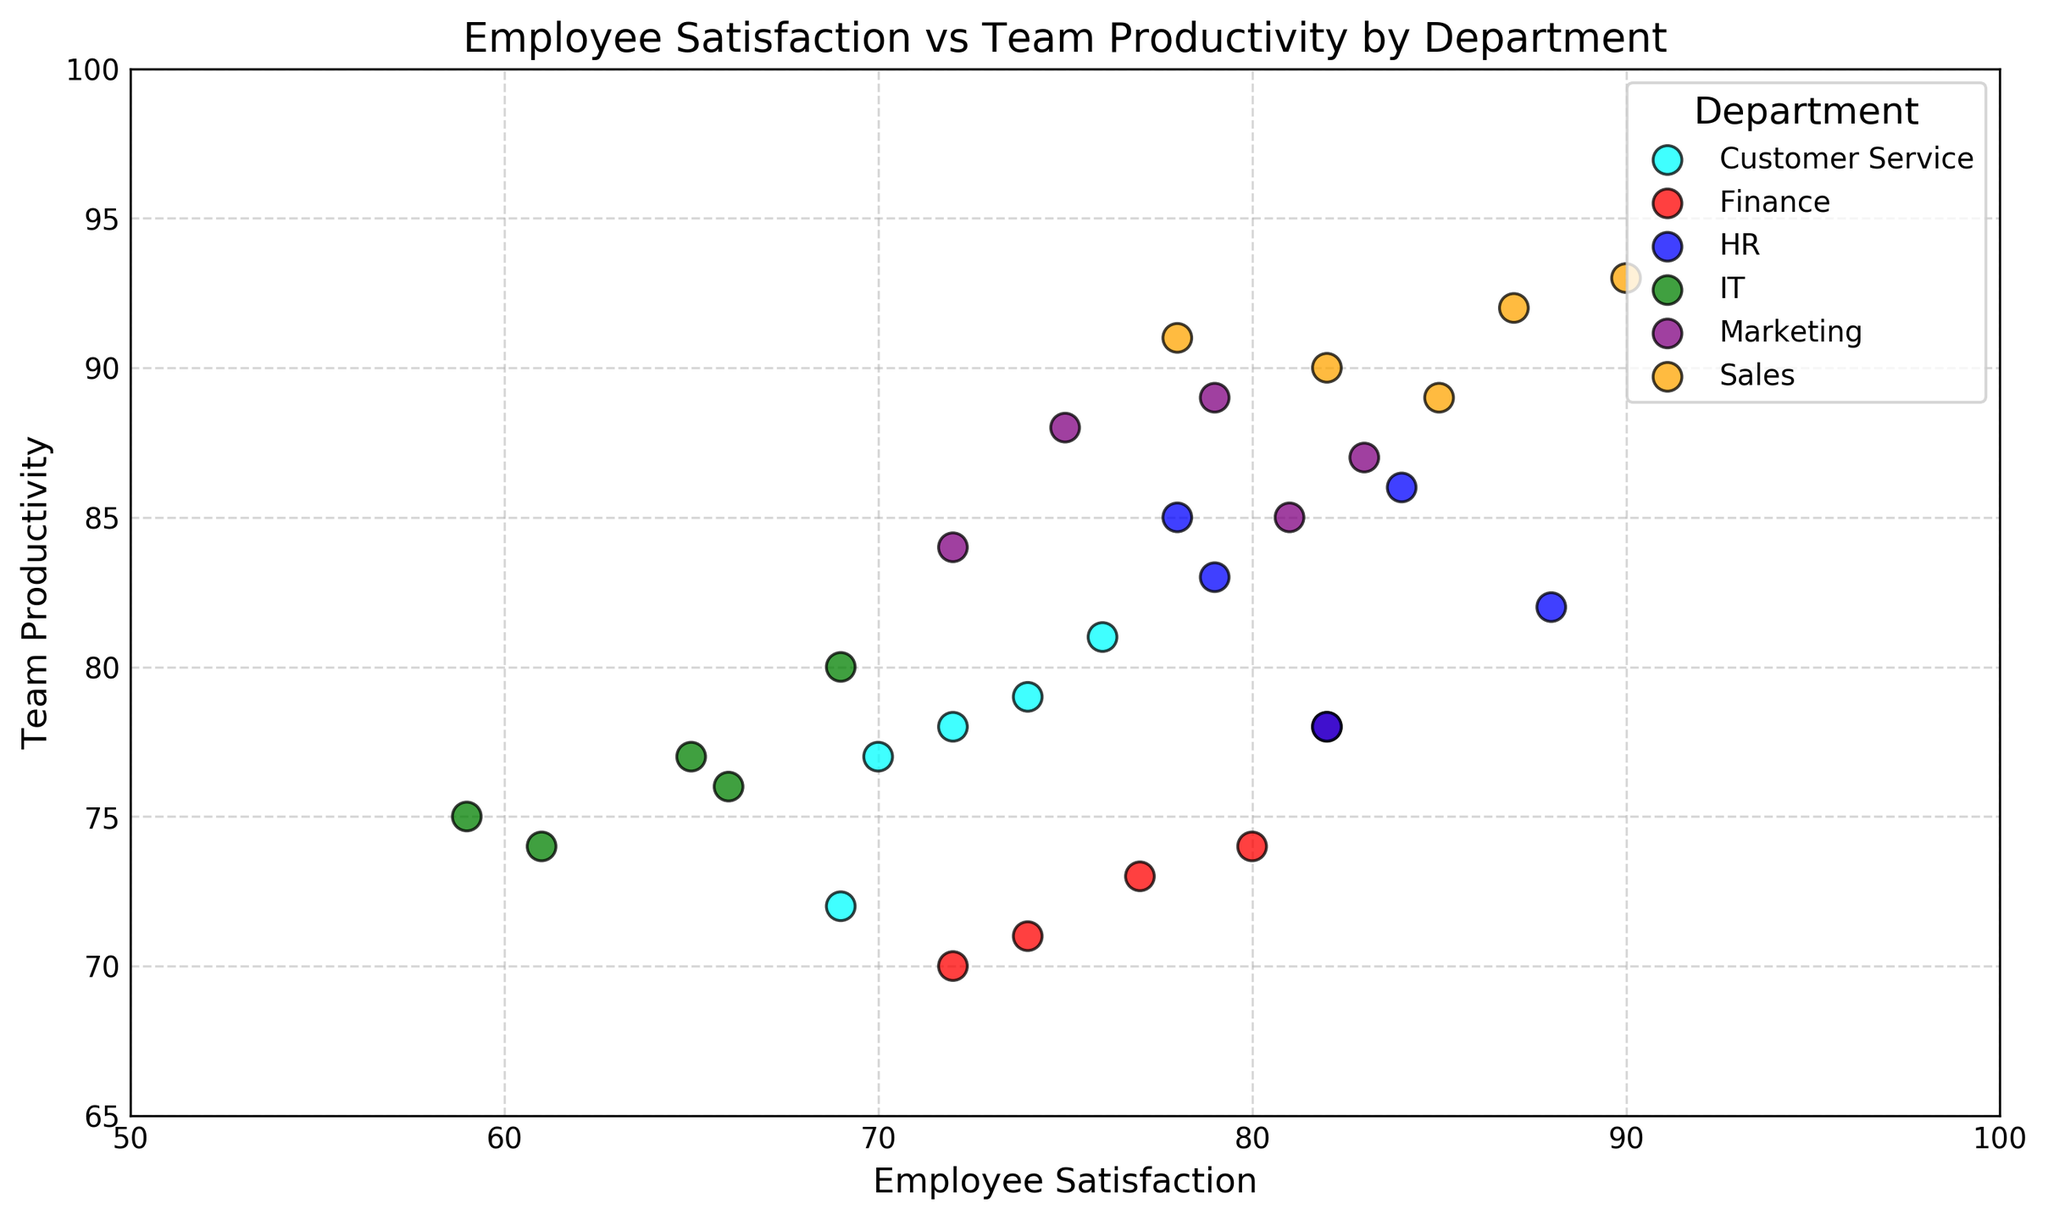What is the range of Employee Satisfaction for the Marketing department? To find the range, identify the maximum and minimum Employee Satisfaction values for the Marketing department. The highest value is 83 and the lowest value is 72, so the range is 83 - 72 = 11.
Answer: 11 Which department has the highest average Team Productivity? Calculate the average Team Productivity for each department and compare. Sales has the highest average at approximately 91.
Answer: Sales Which two departments show the highest correlation between Employee Satisfaction and Team Productivity? A visual inspection of the scatter plot reveals that Sales and Marketing departments show a tight clustering of points, indicating a higher correlation compared to other departments.
Answer: Sales and Marketing What is the difference in Team Productivity between the highest and lowest Satisfaction scores within the IT department? The highest Satisfaction score in IT is 69, and the lowest is 59. The corresponding Productivity scores are 80 and 75. The difference is 80 - 75 = 5.
Answer: 5 Which department’s data points cover the widest range in Team Productivity? Compare the range of Team Productivity for each department. Sales shows a high overarching range from 90 to 93, which is smaller than other departments. HR, ranging from 82 to 86; thus, Customer Service, with a range from 72 to 81, the highest.
Answer: Customer Service What is the average Employee Satisfaction score for the Customer Service department? Calculate the average from the Customer Service satisfaction scores: (76 + 69 + 74 + 70 + 72) / 5 = 72.2.
Answer: 72.2 Which department shows the least variance in Employee Satisfaction? By inspecting the spread of data points in Employee Satisfaction for each department, we see that the HR department has data points closely clustered, indicating low variance.
Answer: HR 